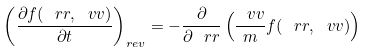<formula> <loc_0><loc_0><loc_500><loc_500>\left ( \frac { \partial f ( \ r r , \ v v ) } { \partial t } \right ) _ { r e v } = - \frac { \partial } { \partial \ r r } \left ( \frac { \ v v } { m } f ( \ r r , \ v v ) \right )</formula> 